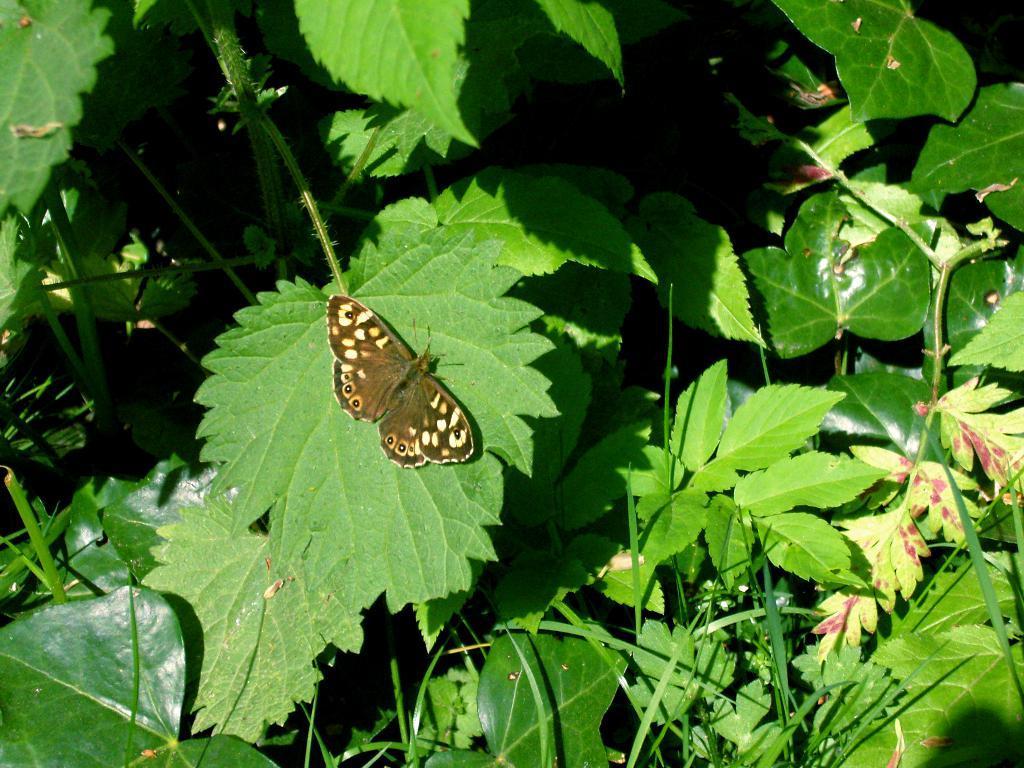Can you describe this image briefly? In this picture I can see the butterfly. I can see the leaves. 